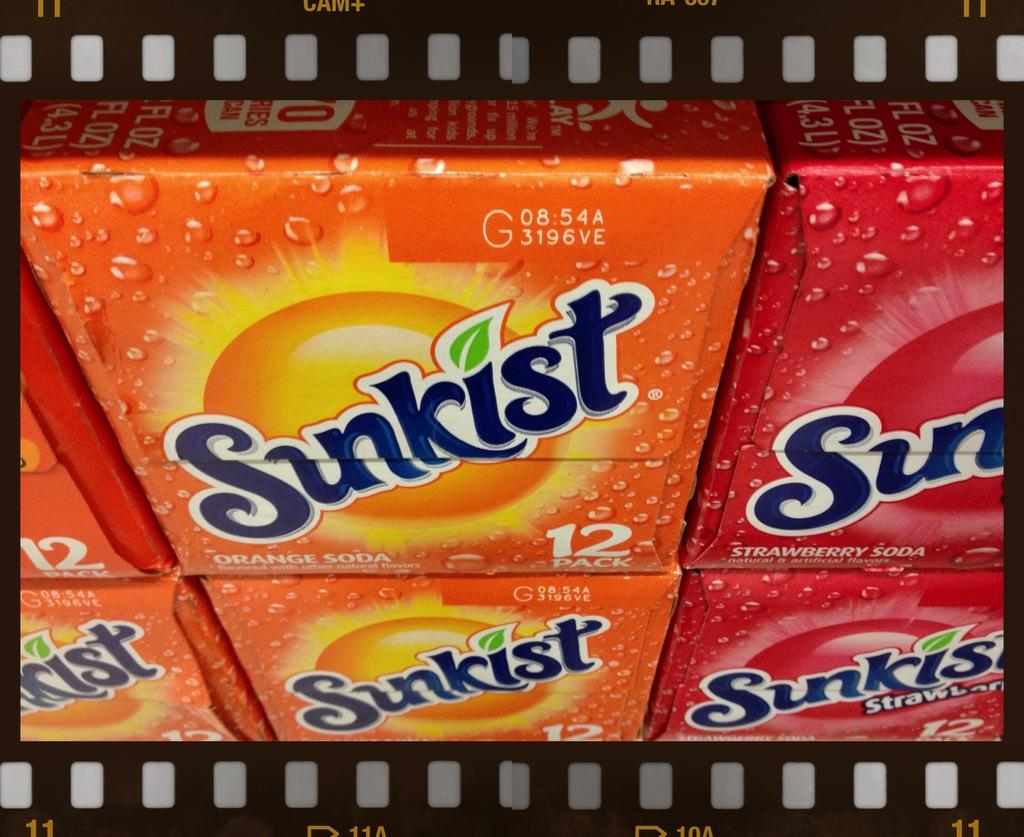What type of beverage is contained in the packets in the image? There are soda packets in the image. How many different flavors of soda are present in the image? There are two different flavors of soda in the packets. What are the two flavors of soda in the image? One flavor is orange, and the other flavor is strawberry. What type of punishment is being given to the soda packets in the image? There is no punishment being given to the soda packets in the image; they are simply packets of soda. 